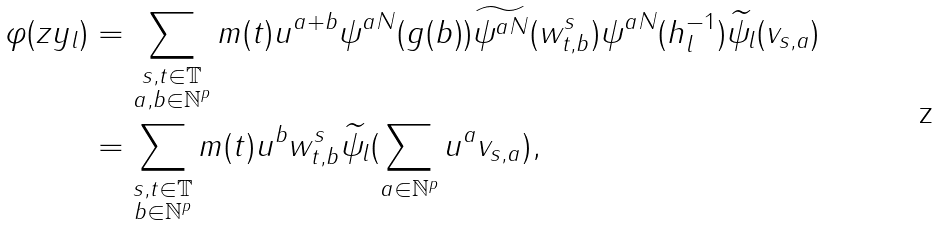Convert formula to latex. <formula><loc_0><loc_0><loc_500><loc_500>\varphi ( z y _ { l } ) & = \sum _ { \substack { s , t \in \mathbb { T } \\ a , b \in \mathbb { N } ^ { p } } } m ( t ) u ^ { a + b } \psi ^ { a N } ( g ( b ) ) \widetilde { \psi ^ { a N } } ( w _ { t , b } ^ { s } ) \psi ^ { a N } ( h _ { l } ^ { - 1 } ) \widetilde { \psi _ { l } } ( v _ { s , a } ) \\ & = \sum _ { \substack { s , t \in \mathbb { T } \\ b \in \mathbb { N } ^ { p } } } m ( t ) u ^ { b } w _ { t , b } ^ { s } \widetilde { \psi _ { l } } ( \sum _ { a \in \mathbb { N } ^ { p } } u ^ { a } v _ { s , a } ) ,</formula> 